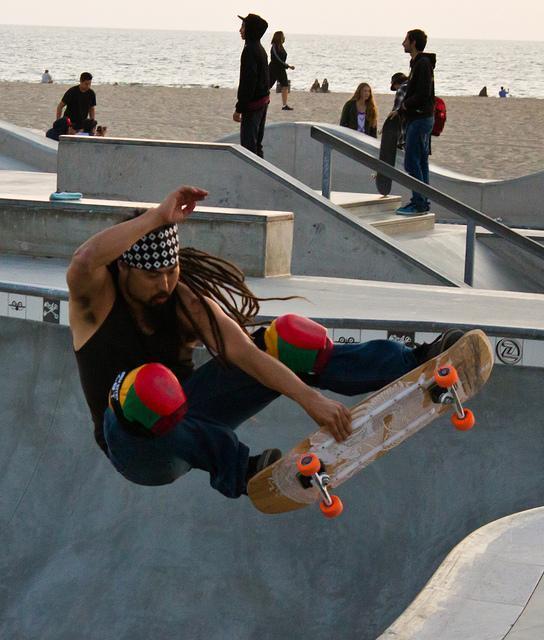How many people are there?
Give a very brief answer. 3. How many surfboards are there?
Give a very brief answer. 0. 